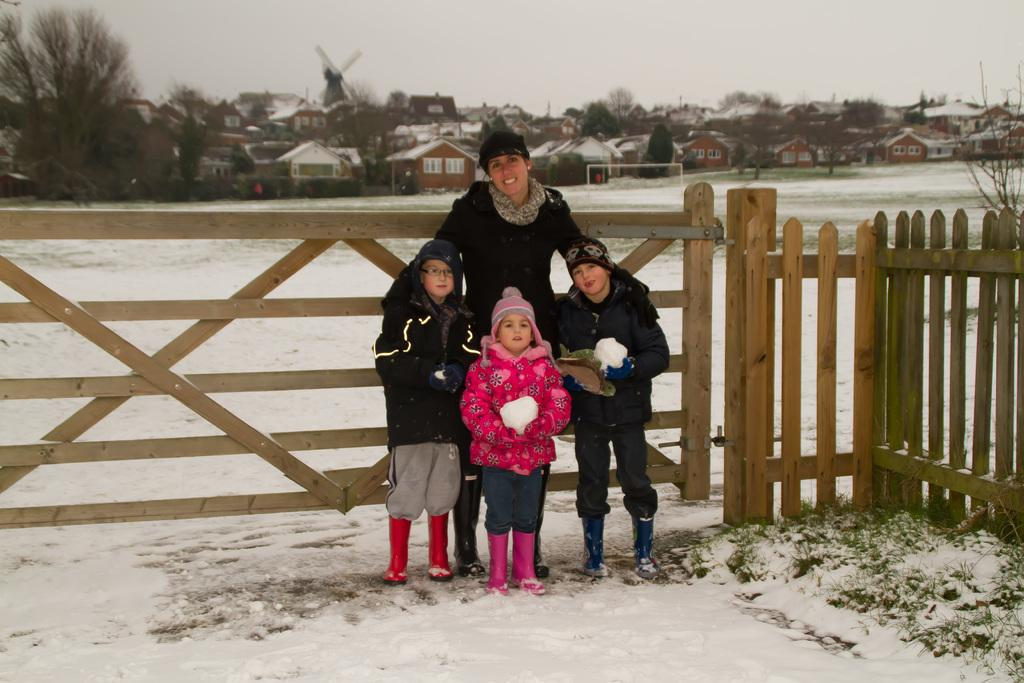Who is present in the image? There is a person and children in the image. What are the person and children doing in the image? The person and children are standing on the ground. What can be seen in the background of the image? There is a wooden fence, snow, houses, trees, and other unspecified objects in the background of the image. What is visible in the sky in the image? The sky is visible in the background of the image. What type of donkey can be seen working with the carpenter in the image? There is no donkey or carpenter present in the image. What season is depicted in the image? The presence of snow in the background suggests that the image is set during winter, but the facts provided do not explicitly mention the season. 